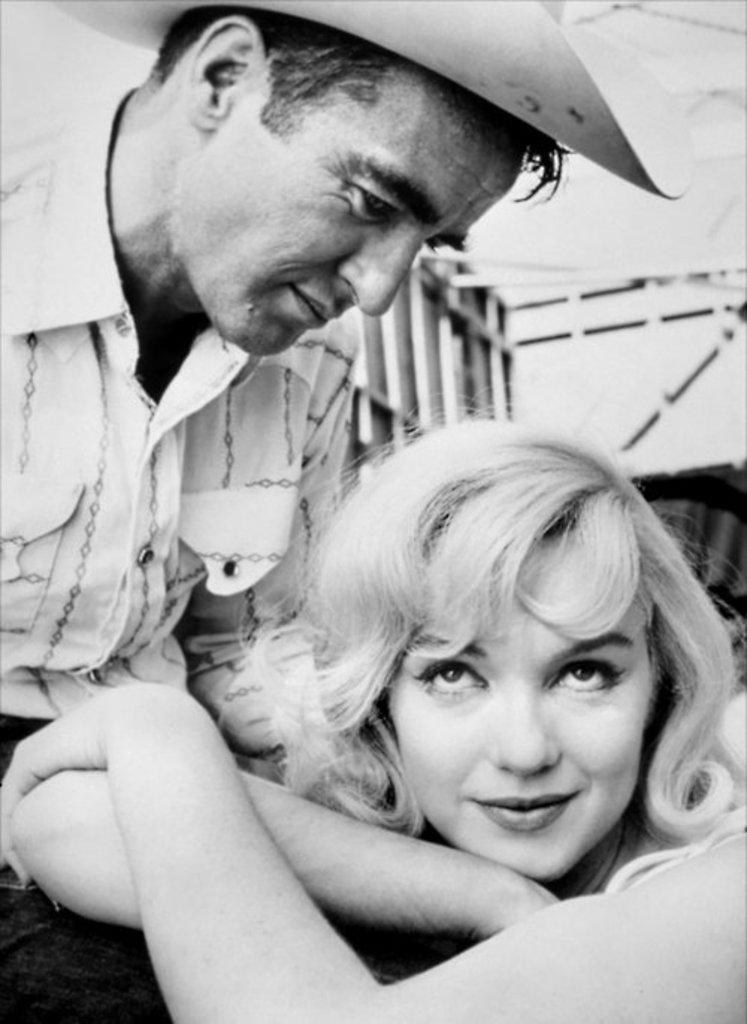How would you summarize this image in a sentence or two? It is the black and white image in which there is a man on the left side who is having a cap on his head. There is a woman on the right side who is keeping her hands on the legs of the man. 